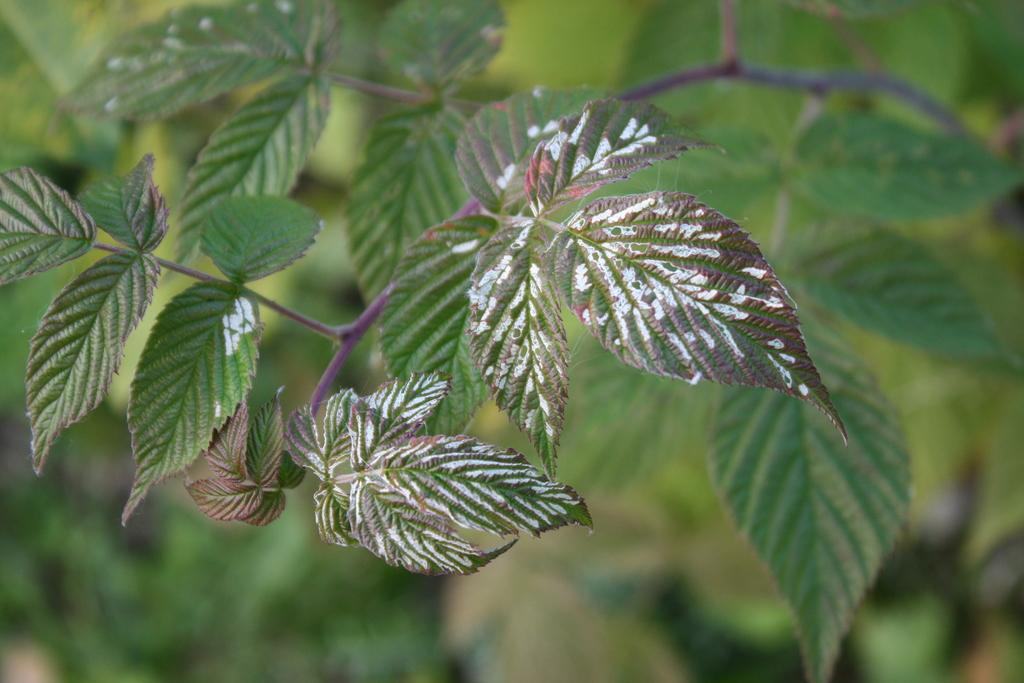What type of vegetation is present in the image? There are green leaves and green stems in the image. Can you describe the background of the image? The background of the image is blurry and green. What type of government is depicted on the sign in the image? There is no sign present in the image, so it is not possible to determine the type of government depicted. 